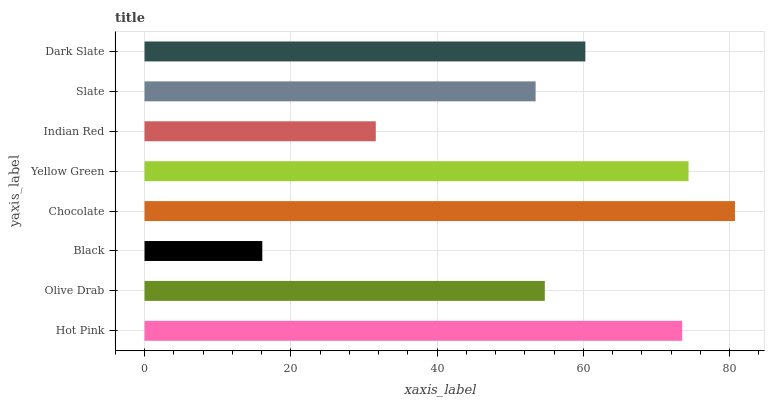Is Black the minimum?
Answer yes or no. Yes. Is Chocolate the maximum?
Answer yes or no. Yes. Is Olive Drab the minimum?
Answer yes or no. No. Is Olive Drab the maximum?
Answer yes or no. No. Is Hot Pink greater than Olive Drab?
Answer yes or no. Yes. Is Olive Drab less than Hot Pink?
Answer yes or no. Yes. Is Olive Drab greater than Hot Pink?
Answer yes or no. No. Is Hot Pink less than Olive Drab?
Answer yes or no. No. Is Dark Slate the high median?
Answer yes or no. Yes. Is Olive Drab the low median?
Answer yes or no. Yes. Is Indian Red the high median?
Answer yes or no. No. Is Indian Red the low median?
Answer yes or no. No. 